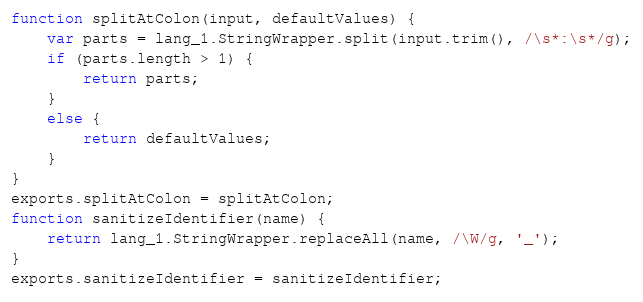<code> <loc_0><loc_0><loc_500><loc_500><_JavaScript_>function splitAtColon(input, defaultValues) {
    var parts = lang_1.StringWrapper.split(input.trim(), /\s*:\s*/g);
    if (parts.length > 1) {
        return parts;
    }
    else {
        return defaultValues;
    }
}
exports.splitAtColon = splitAtColon;
function sanitizeIdentifier(name) {
    return lang_1.StringWrapper.replaceAll(name, /\W/g, '_');
}
exports.sanitizeIdentifier = sanitizeIdentifier;</code> 